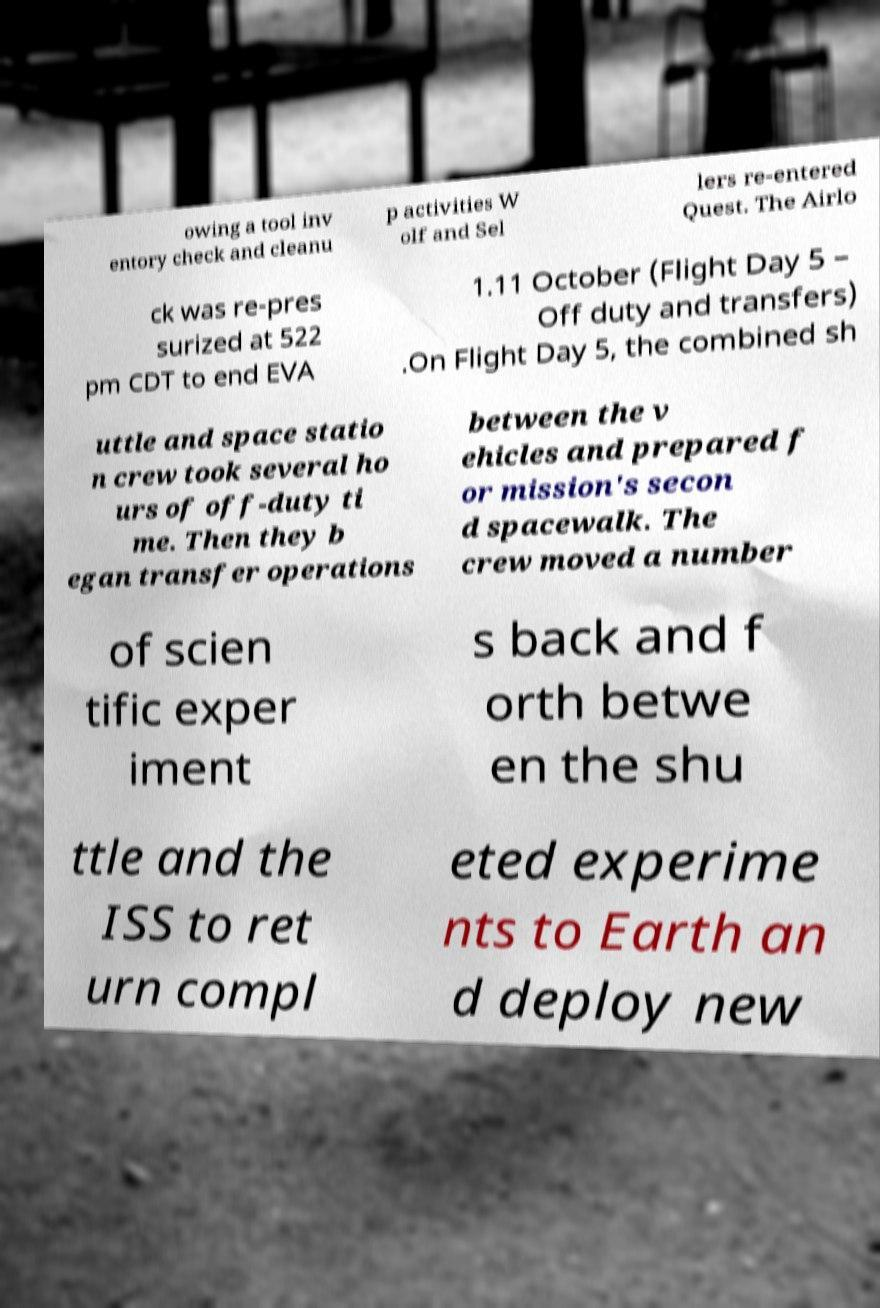Can you read and provide the text displayed in the image?This photo seems to have some interesting text. Can you extract and type it out for me? owing a tool inv entory check and cleanu p activities W olf and Sel lers re-entered Quest. The Airlo ck was re-pres surized at 522 pm CDT to end EVA 1.11 October (Flight Day 5 – Off duty and transfers) .On Flight Day 5, the combined sh uttle and space statio n crew took several ho urs of off-duty ti me. Then they b egan transfer operations between the v ehicles and prepared f or mission's secon d spacewalk. The crew moved a number of scien tific exper iment s back and f orth betwe en the shu ttle and the ISS to ret urn compl eted experime nts to Earth an d deploy new 